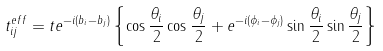Convert formula to latex. <formula><loc_0><loc_0><loc_500><loc_500>t _ { i j } ^ { e f f } = t e ^ { - i ( b _ { i } - b _ { j } ) } \left \{ \cos \frac { \theta _ { i } } { 2 } \cos \frac { \theta _ { j } } { 2 } + e ^ { - i ( \phi _ { i } - \phi _ { j } ) } \sin \frac { \theta _ { i } } { 2 } \sin \frac { \theta _ { j } } { 2 } \right \}</formula> 